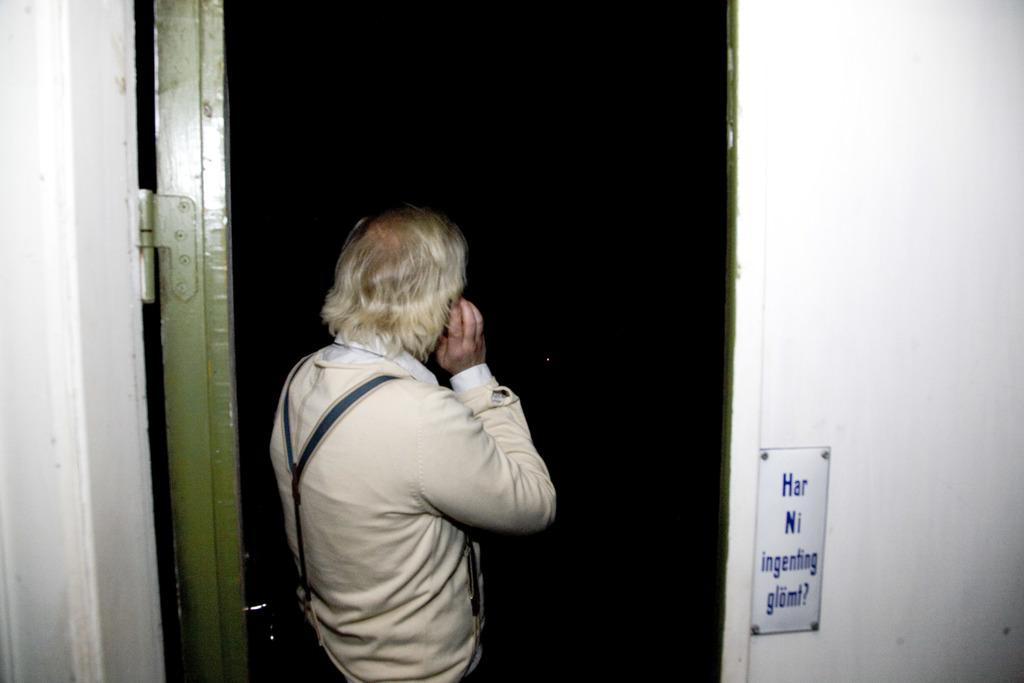What is the main subject of the image? There is a person standing in the image. What architectural features can be seen in the image? There is a door and a wall in the image. What is on the wall in the image? There is a whiteboard with text on the wall. How many pizzas are being delivered by the zephyr in the image? There is no zephyr or pizzas present in the image. 